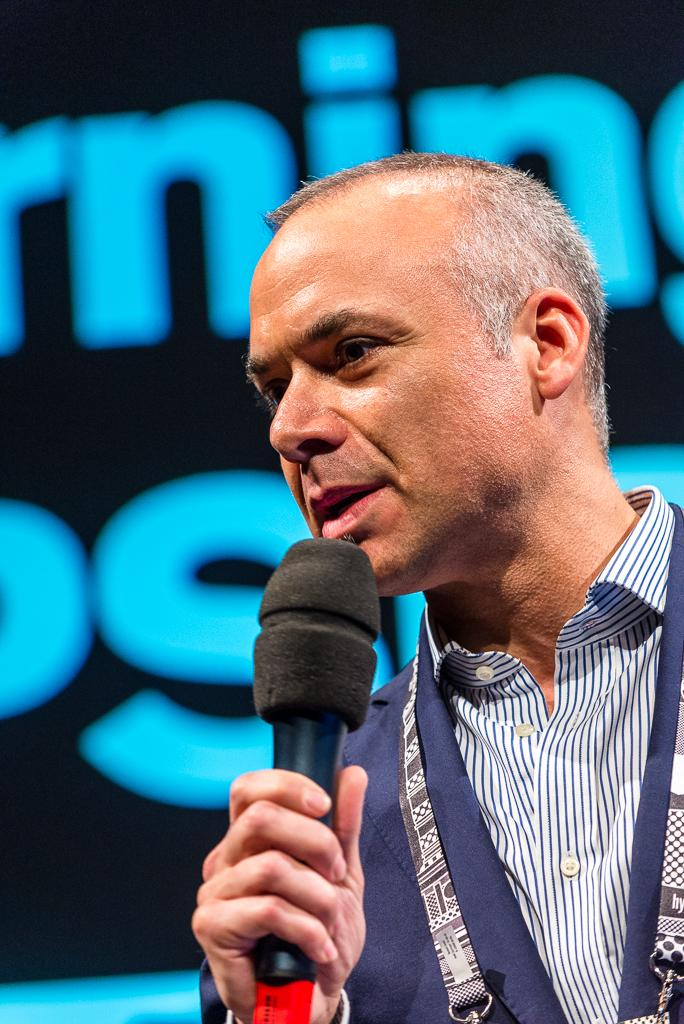What is the main subject of the image? There is a person in the image. What can be observed about the person's attire? The person is wearing clothes. What is the person holding in the image? The person is holding a mic with his hand. Can you describe the background of the image? The background of the image is blurred. What type of juice is the person drinking in the image? There is no juice present in the image; the person is holding a mic. In which direction is the person facing in the image? The provided facts do not mention the direction the person is facing, so it cannot be determined from the image. 